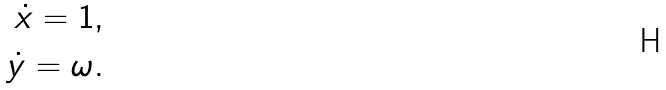Convert formula to latex. <formula><loc_0><loc_0><loc_500><loc_500>\dot { x } = 1 , \\ \dot { y } = \omega .</formula> 